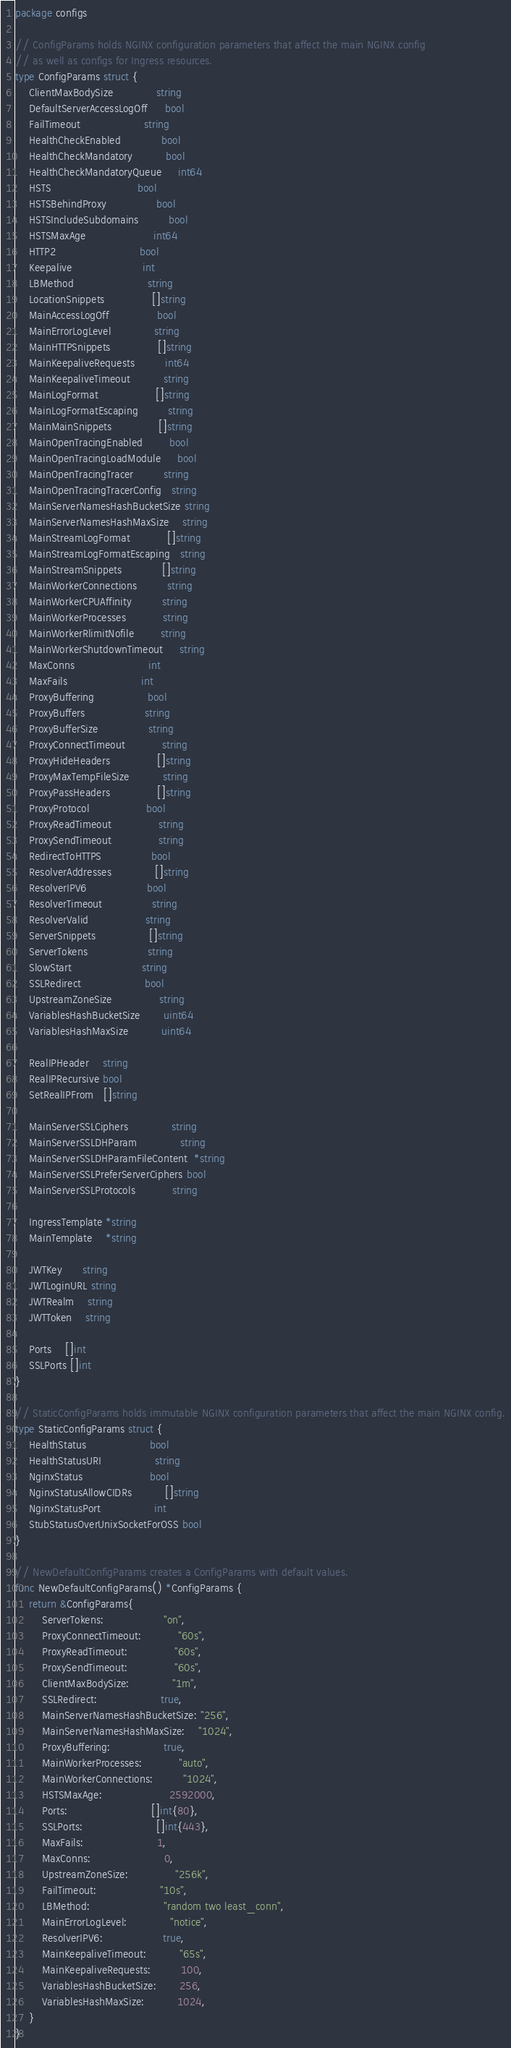Convert code to text. <code><loc_0><loc_0><loc_500><loc_500><_Go_>package configs

// ConfigParams holds NGINX configuration parameters that affect the main NGINX config
// as well as configs for Ingress resources.
type ConfigParams struct {
	ClientMaxBodySize             string
	DefaultServerAccessLogOff     bool
	FailTimeout                   string
	HealthCheckEnabled            bool
	HealthCheckMandatory          bool
	HealthCheckMandatoryQueue     int64
	HSTS                          bool
	HSTSBehindProxy               bool
	HSTSIncludeSubdomains         bool
	HSTSMaxAge                    int64
	HTTP2                         bool
	Keepalive                     int
	LBMethod                      string
	LocationSnippets              []string
	MainAccessLogOff              bool
	MainErrorLogLevel             string
	MainHTTPSnippets              []string
	MainKeepaliveRequests         int64
	MainKeepaliveTimeout          string
	MainLogFormat                 []string
	MainLogFormatEscaping         string
	MainMainSnippets              []string
	MainOpenTracingEnabled        bool
	MainOpenTracingLoadModule     bool
	MainOpenTracingTracer         string
	MainOpenTracingTracerConfig   string
	MainServerNamesHashBucketSize string
	MainServerNamesHashMaxSize    string
	MainStreamLogFormat           []string
	MainStreamLogFormatEscaping   string
	MainStreamSnippets            []string
	MainWorkerConnections         string
	MainWorkerCPUAffinity         string
	MainWorkerProcesses           string
	MainWorkerRlimitNofile        string
	MainWorkerShutdownTimeout     string
	MaxConns                      int
	MaxFails                      int
	ProxyBuffering                bool
	ProxyBuffers                  string
	ProxyBufferSize               string
	ProxyConnectTimeout           string
	ProxyHideHeaders              []string
	ProxyMaxTempFileSize          string
	ProxyPassHeaders              []string
	ProxyProtocol                 bool
	ProxyReadTimeout              string
	ProxySendTimeout              string
	RedirectToHTTPS               bool
	ResolverAddresses             []string
	ResolverIPV6                  bool
	ResolverTimeout               string
	ResolverValid                 string
	ServerSnippets                []string
	ServerTokens                  string
	SlowStart                     string
	SSLRedirect                   bool
	UpstreamZoneSize              string
	VariablesHashBucketSize       uint64
	VariablesHashMaxSize          uint64

	RealIPHeader    string
	RealIPRecursive bool
	SetRealIPFrom   []string

	MainServerSSLCiphers             string
	MainServerSSLDHParam             string
	MainServerSSLDHParamFileContent  *string
	MainServerSSLPreferServerCiphers bool
	MainServerSSLProtocols           string

	IngressTemplate *string
	MainTemplate    *string

	JWTKey      string
	JWTLoginURL string
	JWTRealm    string
	JWTToken    string

	Ports    []int
	SSLPorts []int
}

// StaticConfigParams holds immutable NGINX configuration parameters that affect the main NGINX config.
type StaticConfigParams struct {
	HealthStatus                   bool
	HealthStatusURI                string
	NginxStatus                    bool
	NginxStatusAllowCIDRs          []string
	NginxStatusPort                int
	StubStatusOverUnixSocketForOSS bool
}

// NewDefaultConfigParams creates a ConfigParams with default values.
func NewDefaultConfigParams() *ConfigParams {
	return &ConfigParams{
		ServerTokens:                  "on",
		ProxyConnectTimeout:           "60s",
		ProxyReadTimeout:              "60s",
		ProxySendTimeout:              "60s",
		ClientMaxBodySize:             "1m",
		SSLRedirect:                   true,
		MainServerNamesHashBucketSize: "256",
		MainServerNamesHashMaxSize:    "1024",
		ProxyBuffering:                true,
		MainWorkerProcesses:           "auto",
		MainWorkerConnections:         "1024",
		HSTSMaxAge:                    2592000,
		Ports:                         []int{80},
		SSLPorts:                      []int{443},
		MaxFails:                      1,
		MaxConns:                      0,
		UpstreamZoneSize:              "256k",
		FailTimeout:                   "10s",
		LBMethod:                      "random two least_conn",
		MainErrorLogLevel:             "notice",
		ResolverIPV6:                  true,
		MainKeepaliveTimeout:          "65s",
		MainKeepaliveRequests:         100,
		VariablesHashBucketSize:       256,
		VariablesHashMaxSize:          1024,
	}
}
</code> 